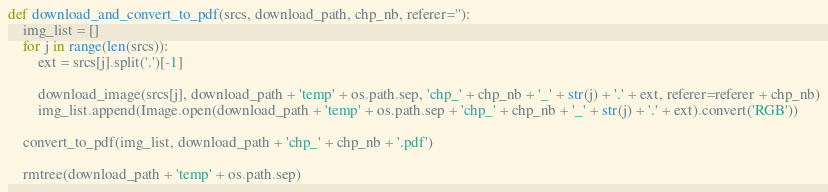Convert code to text. <code><loc_0><loc_0><loc_500><loc_500><_Python_>
def download_and_convert_to_pdf(srcs, download_path, chp_nb, referer=''):
    img_list = []
    for j in range(len(srcs)):
        ext = srcs[j].split('.')[-1]

        download_image(srcs[j], download_path + 'temp' + os.path.sep, 'chp_' + chp_nb + '_' + str(j) + '.' + ext, referer=referer + chp_nb)
        img_list.append(Image.open(download_path + 'temp' + os.path.sep + 'chp_' + chp_nb + '_' + str(j) + '.' + ext).convert('RGB'))

    convert_to_pdf(img_list, download_path + 'chp_' + chp_nb + '.pdf')

    rmtree(download_path + 'temp' + os.path.sep)</code> 